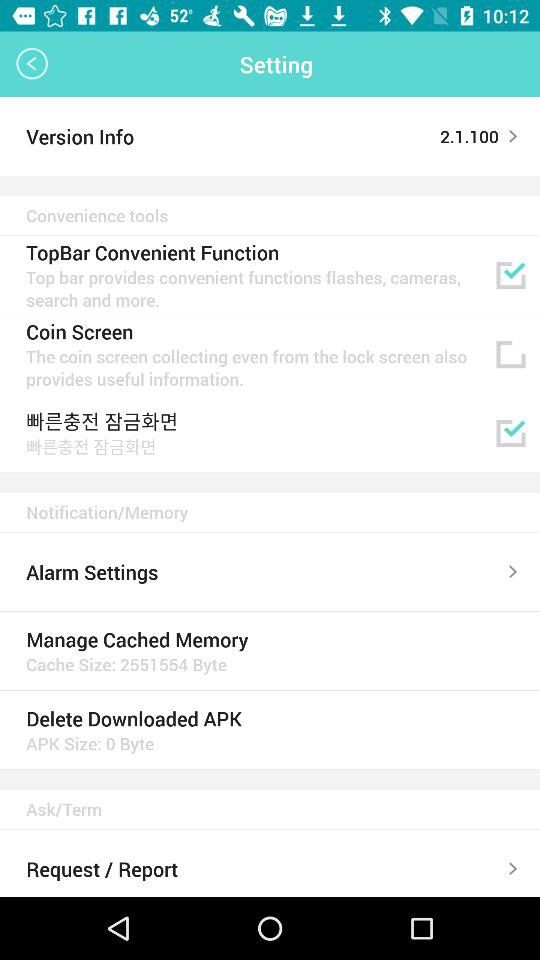How many items are in the Convenience tools section?
Answer the question using a single word or phrase. 3 